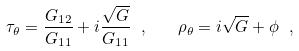<formula> <loc_0><loc_0><loc_500><loc_500>\tau _ { \theta } = \frac { G _ { 1 2 } } { G _ { 1 1 } } + i \frac { \sqrt { G } } { G _ { 1 1 } } \ , \quad \rho _ { \theta } = i \sqrt { G } + \phi \ ,</formula> 